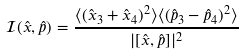<formula> <loc_0><loc_0><loc_500><loc_500>\mathcal { I } ( \hat { x } , \hat { p } ) = \frac { \langle ( \hat { x } _ { 3 } + \hat { x } _ { 4 } ) ^ { 2 } \rangle \langle ( \hat { p } _ { 3 } - \hat { p } _ { 4 } ) ^ { 2 } \rangle } { | [ \hat { x } , \hat { p } ] | ^ { 2 } }</formula> 